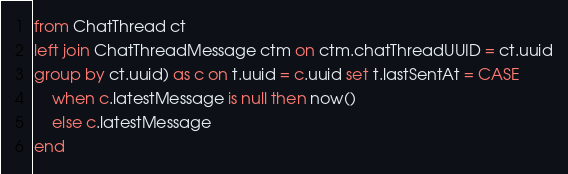<code> <loc_0><loc_0><loc_500><loc_500><_SQL_>from ChatThread ct
left join ChatThreadMessage ctm on ctm.chatThreadUUID = ct.uuid
group by ct.uuid) as c on t.uuid = c.uuid set t.lastSentAt = CASE
    when c.latestMessage is null then now()
    else c.latestMessage
end</code> 